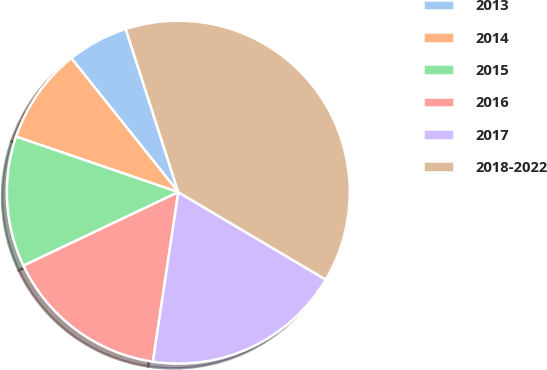Convert chart. <chart><loc_0><loc_0><loc_500><loc_500><pie_chart><fcel>2013<fcel>2014<fcel>2015<fcel>2016<fcel>2017<fcel>2018-2022<nl><fcel>5.76%<fcel>9.03%<fcel>12.3%<fcel>15.58%<fcel>18.85%<fcel>38.49%<nl></chart> 